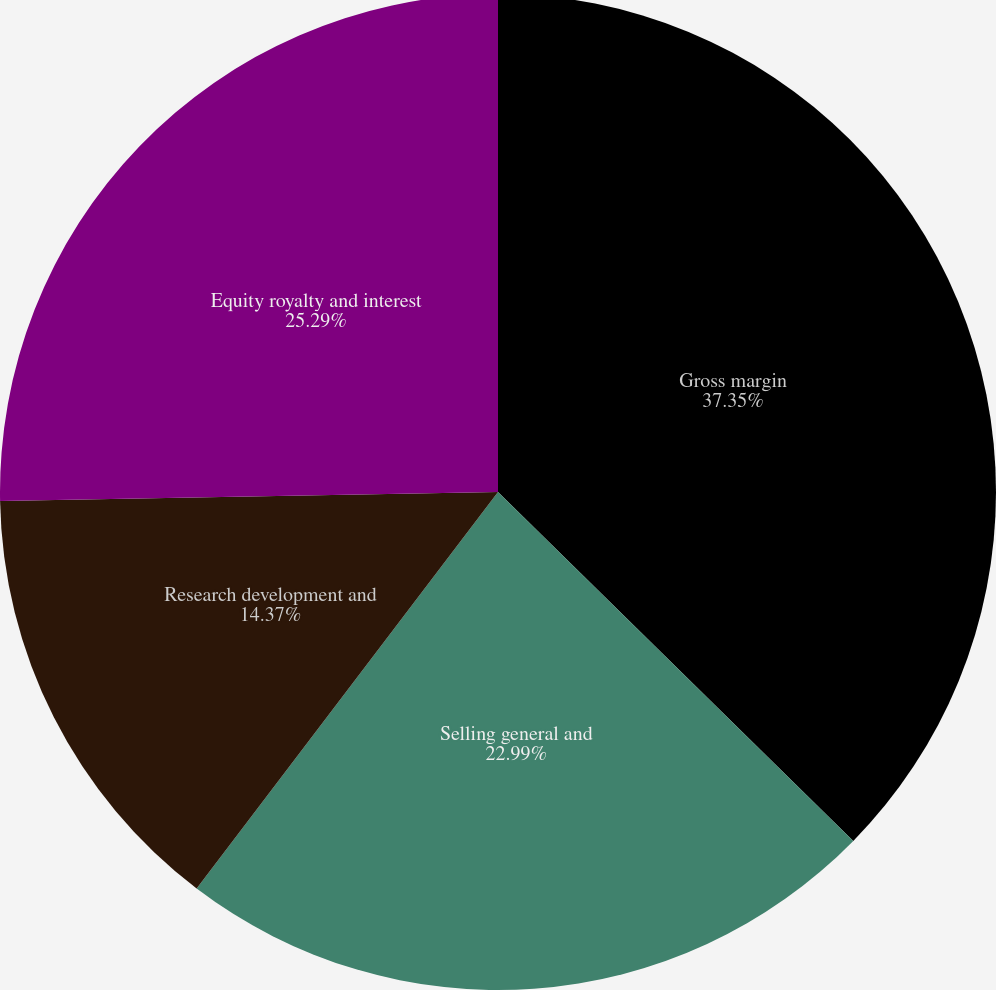Convert chart to OTSL. <chart><loc_0><loc_0><loc_500><loc_500><pie_chart><fcel>Gross margin<fcel>Selling general and<fcel>Research development and<fcel>Equity royalty and interest<nl><fcel>37.36%<fcel>22.99%<fcel>14.37%<fcel>25.29%<nl></chart> 